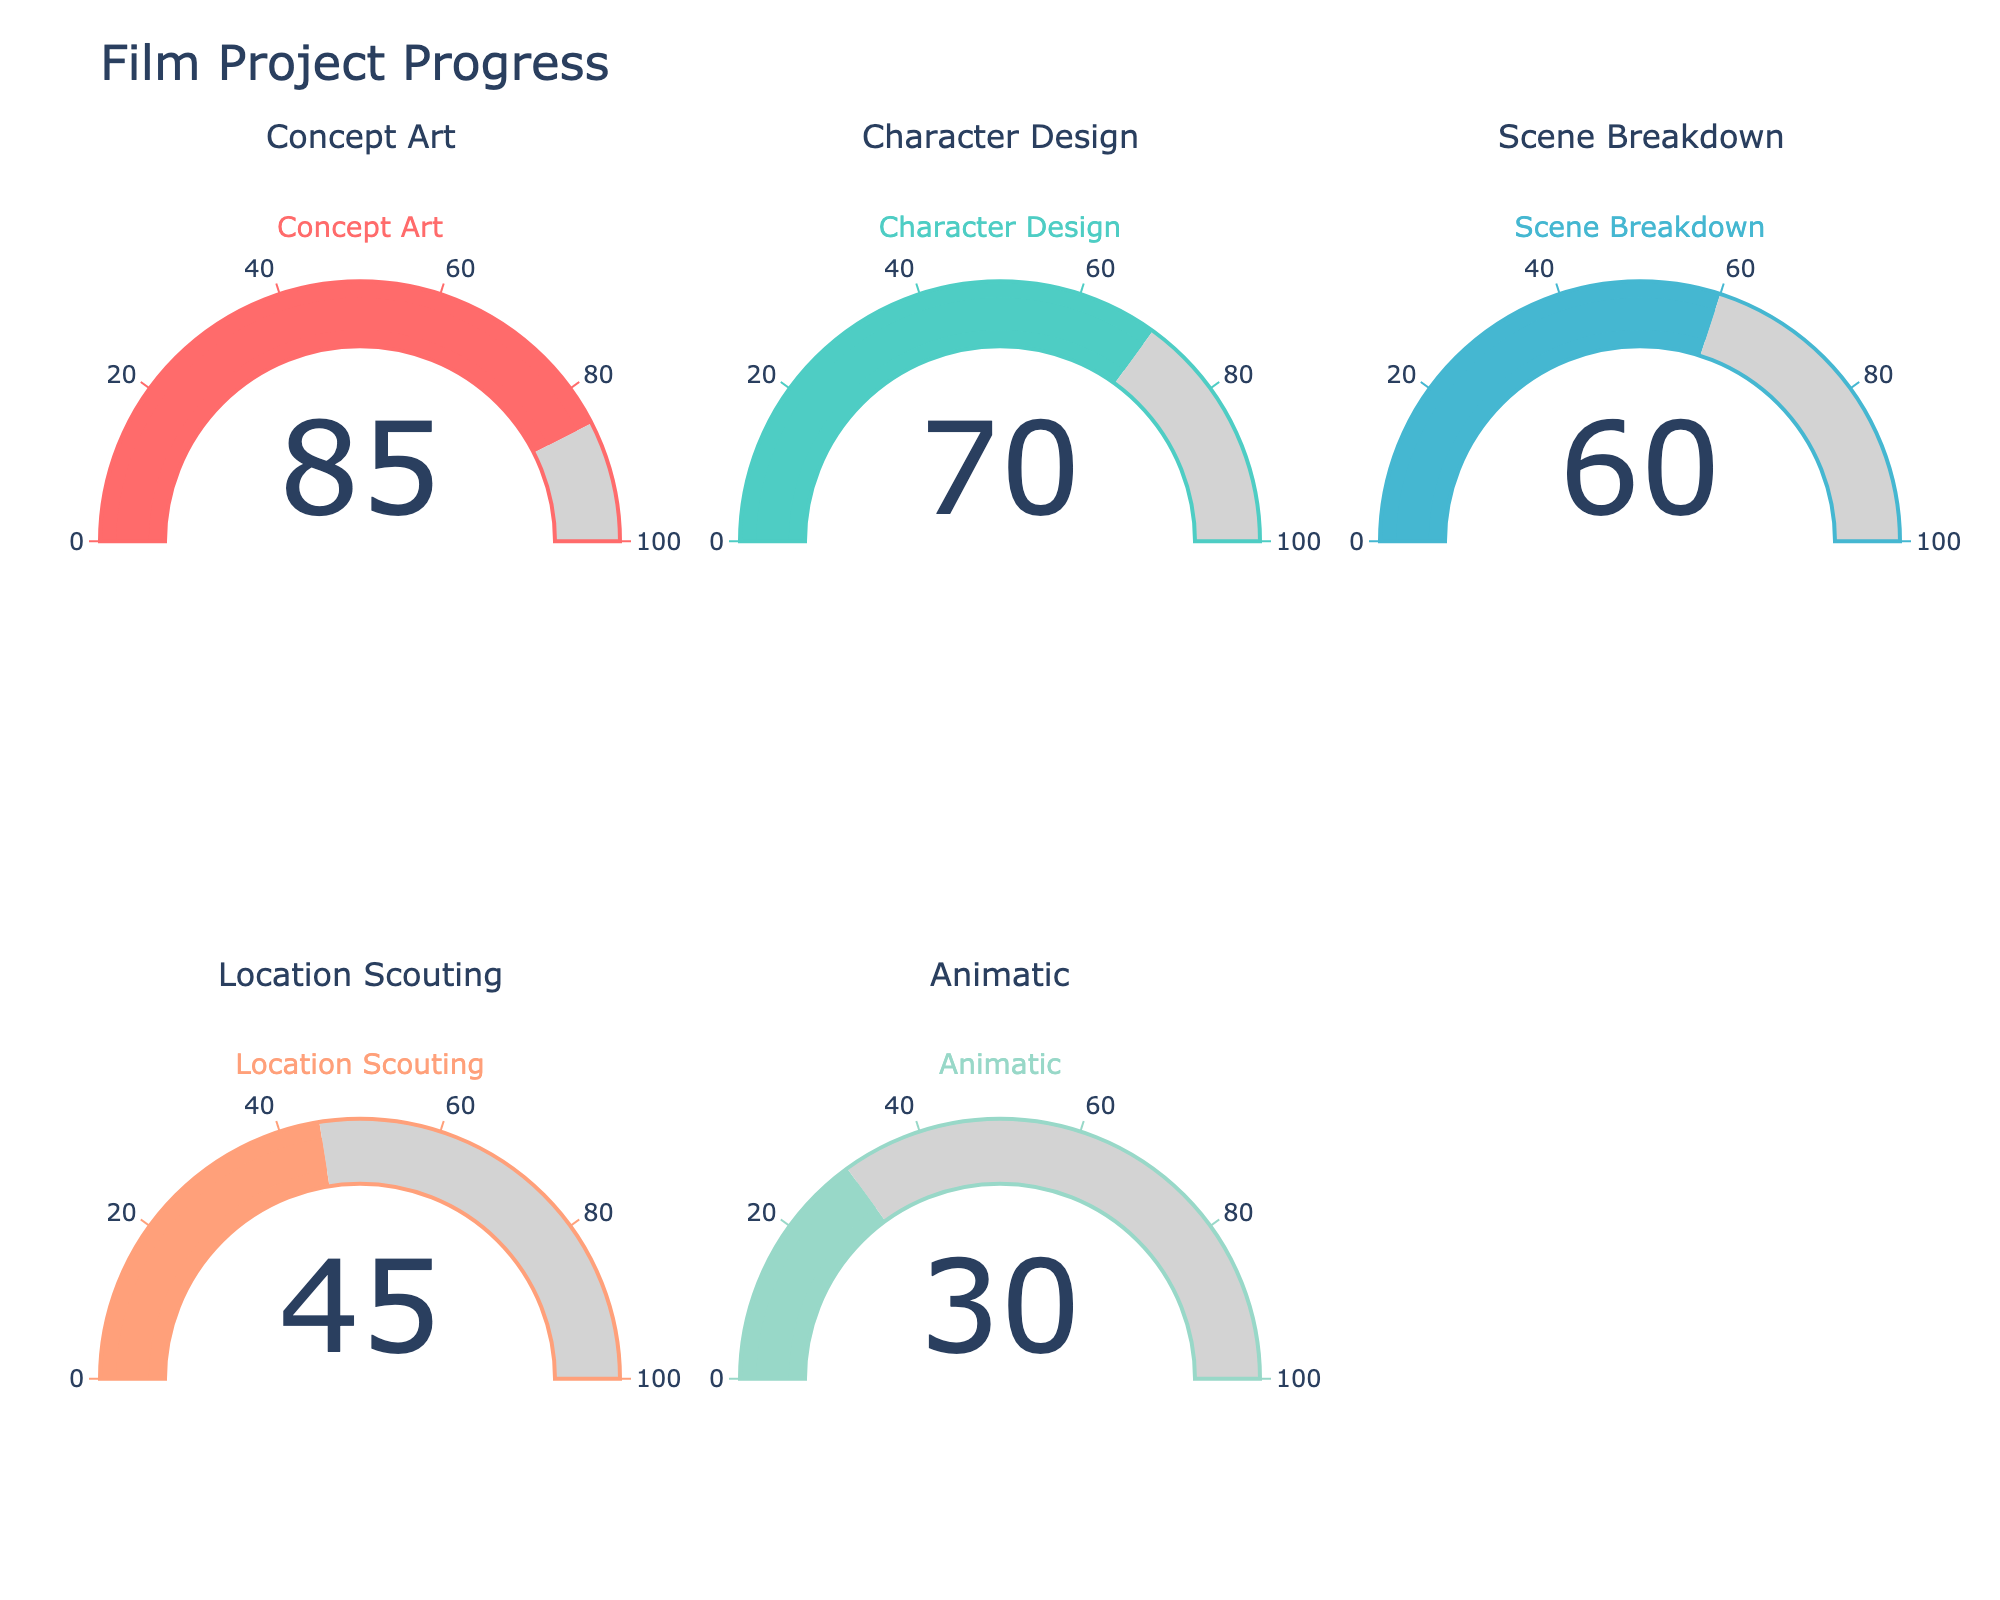What's the title of the figure? The title of the figure appears at the top and is a key element of understanding what the figure represents. In this case, it's "Film Project Progress."
Answer: Film Project Progress What's the completion percentage for the Character Design stage? Look at the gauge labeled "Character Design" and check the number displayed in the center of the gauge, which indicates the completion percentage.
Answer: 70 Which stage has the lowest completion percentage? Compare the values shown in the center of each gauge to identify the lowest one. The gauge labeled "Animatic" has the lowest value.
Answer: Animatic How much more is the Concept Art stage completed compared to the Scene Breakdown stage? Subtract the completion percentage of Scene Breakdown from that of Concept Art (85 - 60).
Answer: 25 Which stage is more complete: Location Scouting or Character Design? Compare the values displayed in the gauges for Location Scouting and Character Design. Character Design is more complete.
Answer: Character Design What is the average completion percentage across all stages? Add up all the completion percentages (85 + 70 + 60 + 45 + 30) and divide by the number of stages (5). The calculation is as follows: (85 + 70 + 60 + 45 + 30) / 5 = 58.
Answer: 58 What color represents the Animatic stage? Identify the gauge labeled "Animatic" and note the color of the gauge bar. It is the last color in the list, which is a pastel green (roughly described as 'light green').
Answer: Light green Is the completion percentage of Location Scouting greater than halfway to full completion? Check if the value for Location Scouting is greater than 50. The completion percentage is 45, which is less than halfway (50).
Answer: No What's the median completion percentage for the stages? Arrange the completion percentages in ascending order (30, 45, 60, 70, 85) and identify the middle value. Since there are 5 stages, the middle value is the third number in the list.
Answer: 60 